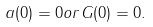Convert formula to latex. <formula><loc_0><loc_0><loc_500><loc_500>a ( 0 ) = 0 o r G ( 0 ) = 0 .</formula> 